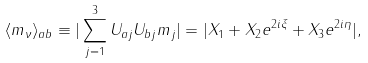<formula> <loc_0><loc_0><loc_500><loc_500>\langle m _ { \nu } \rangle _ { a b } \equiv | \sum _ { j = 1 } ^ { 3 } U _ { a j } U _ { b j } m _ { j } | = | X _ { 1 } + X _ { 2 } e ^ { 2 i \xi } + X _ { 3 } e ^ { 2 i \eta } | ,</formula> 